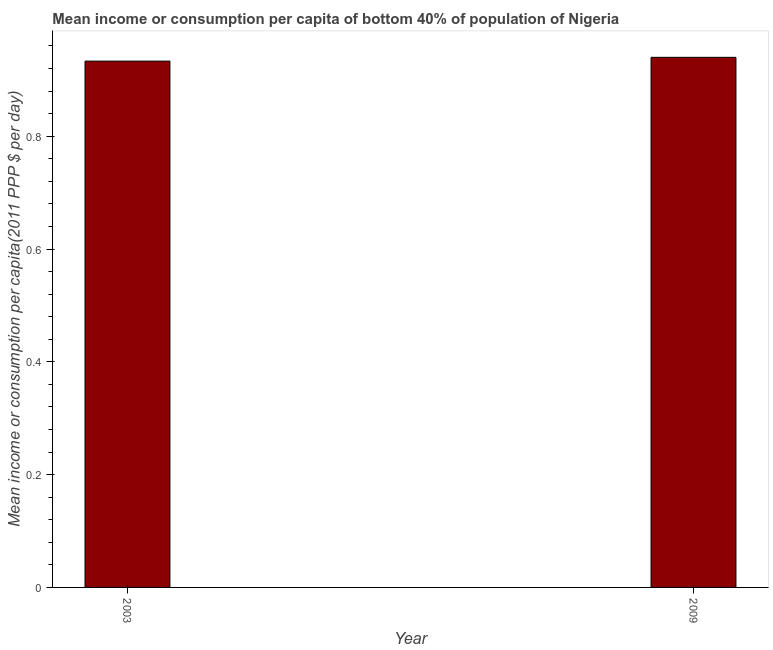Does the graph contain any zero values?
Your answer should be compact. No. What is the title of the graph?
Your answer should be very brief. Mean income or consumption per capita of bottom 40% of population of Nigeria. What is the label or title of the Y-axis?
Make the answer very short. Mean income or consumption per capita(2011 PPP $ per day). What is the mean income or consumption in 2009?
Make the answer very short. 0.94. Across all years, what is the maximum mean income or consumption?
Give a very brief answer. 0.94. Across all years, what is the minimum mean income or consumption?
Your response must be concise. 0.93. In which year was the mean income or consumption minimum?
Your answer should be very brief. 2003. What is the sum of the mean income or consumption?
Make the answer very short. 1.87. What is the difference between the mean income or consumption in 2003 and 2009?
Offer a very short reply. -0.01. What is the average mean income or consumption per year?
Offer a very short reply. 0.94. What is the median mean income or consumption?
Your answer should be compact. 0.94. In how many years, is the mean income or consumption greater than 0.52 $?
Your response must be concise. 2. What is the ratio of the mean income or consumption in 2003 to that in 2009?
Your answer should be very brief. 0.99. What is the difference between two consecutive major ticks on the Y-axis?
Ensure brevity in your answer.  0.2. Are the values on the major ticks of Y-axis written in scientific E-notation?
Make the answer very short. No. What is the Mean income or consumption per capita(2011 PPP $ per day) of 2003?
Ensure brevity in your answer.  0.93. What is the Mean income or consumption per capita(2011 PPP $ per day) in 2009?
Give a very brief answer. 0.94. What is the difference between the Mean income or consumption per capita(2011 PPP $ per day) in 2003 and 2009?
Keep it short and to the point. -0.01. 